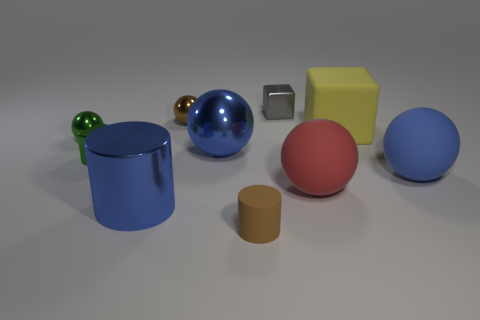Subtract all rubber balls. How many balls are left? 3 Subtract all red balls. How many balls are left? 4 Subtract all cylinders. How many objects are left? 8 Subtract 0 green cylinders. How many objects are left? 10 Subtract 1 cylinders. How many cylinders are left? 1 Subtract all green balls. Subtract all red blocks. How many balls are left? 4 Subtract all cyan cylinders. How many purple cubes are left? 0 Subtract all tiny cylinders. Subtract all brown things. How many objects are left? 7 Add 3 tiny balls. How many tiny balls are left? 5 Add 2 spheres. How many spheres exist? 7 